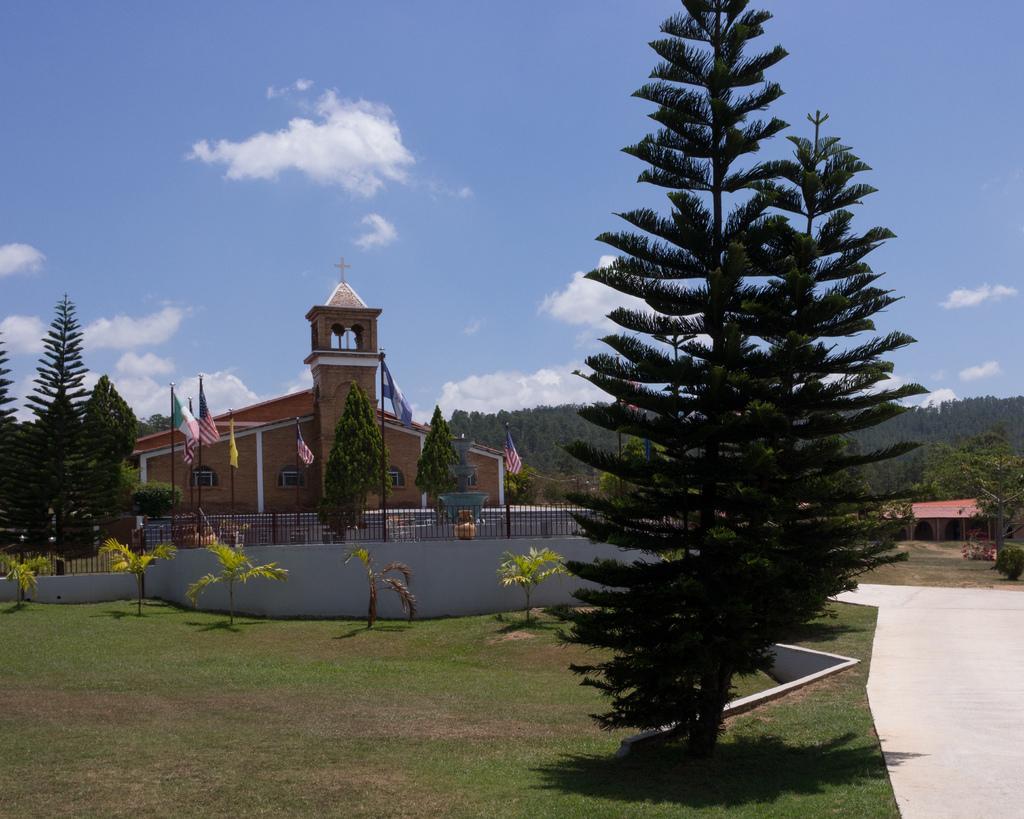Can you describe this image briefly? In this image, we can see houses, flags with poles, trees, plants, grills. At the bottom, there is a grass and footpath. Top of the image, we can see the sky with clouds, holy cross. 